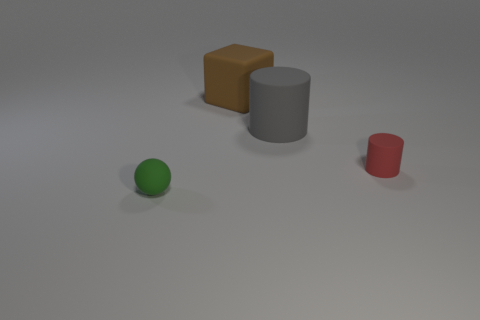Are there the same number of large gray matte things that are on the right side of the large gray matte cylinder and objects that are in front of the red object?
Keep it short and to the point. No. Is the size of the red matte object the same as the cylinder behind the small rubber cylinder?
Make the answer very short. No. Are there more large gray rubber cylinders behind the small red object than large blue objects?
Offer a terse response. Yes. How many brown blocks are the same size as the brown matte object?
Ensure brevity in your answer.  0. There is a object that is on the left side of the rubber block; does it have the same size as the gray matte cylinder that is in front of the brown rubber thing?
Keep it short and to the point. No. Is the number of big brown matte cubes that are in front of the tiny green rubber ball greater than the number of gray objects left of the matte block?
Your response must be concise. No. What number of other green matte things are the same shape as the green rubber object?
Keep it short and to the point. 0. Is there a tiny object made of the same material as the large cylinder?
Provide a short and direct response. Yes. Are there fewer large rubber cubes to the left of the tiny green rubber ball than purple matte objects?
Offer a very short reply. No. What is the large brown thing on the left side of the tiny thing on the right side of the tiny matte ball made of?
Ensure brevity in your answer.  Rubber. 